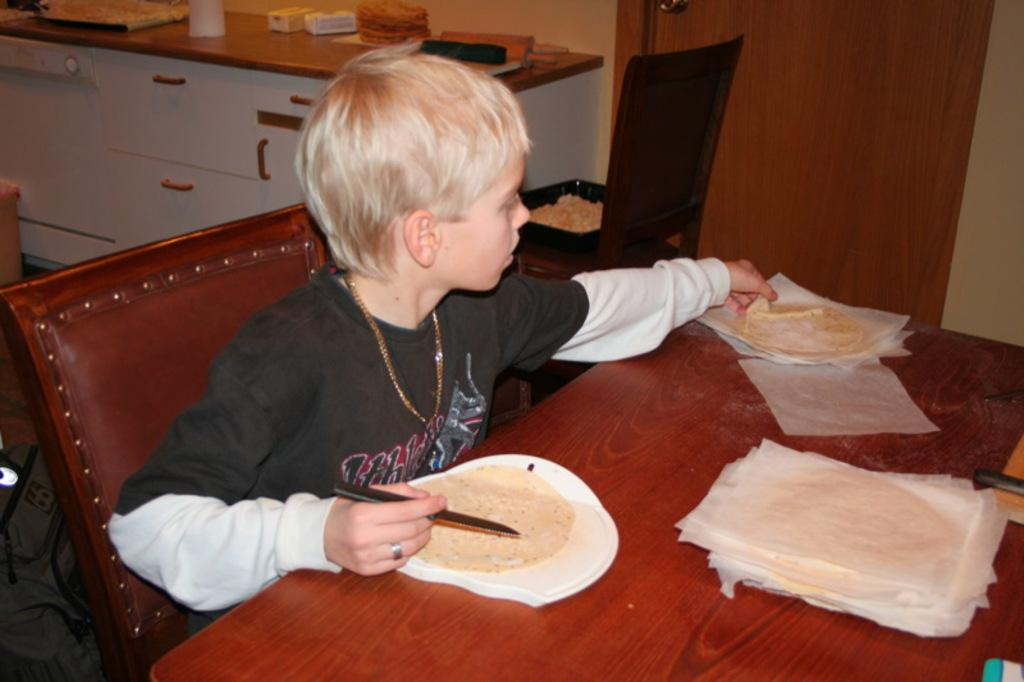Who is the main subject in the image? There is a boy in the image. What is the boy doing in the image? The boy is sitting on a chair. Where is the chair located in relation to the table? The chair is in front of a table. What can be seen on the table? There is food placed on the table. What is visible in the background of the image? There are items placed on a desk in the background of the image. What type of card does the boy have in his hand in the image? There is no card visible in the boy's hand or anywhere in the image. 